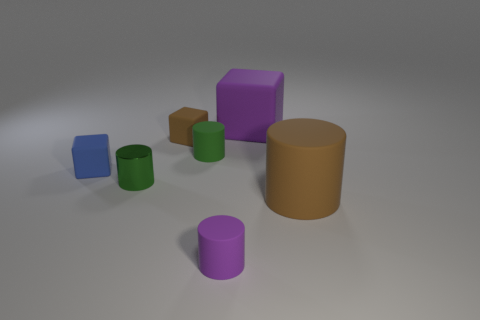Subtract all tiny shiny cylinders. How many cylinders are left? 3 Subtract all cyan cylinders. Subtract all brown blocks. How many cylinders are left? 4 Add 1 small blue balls. How many objects exist? 8 Subtract all blocks. How many objects are left? 4 Subtract all rubber cylinders. Subtract all large purple things. How many objects are left? 3 Add 6 small purple cylinders. How many small purple cylinders are left? 7 Add 5 tiny rubber cylinders. How many tiny rubber cylinders exist? 7 Subtract 1 purple cubes. How many objects are left? 6 